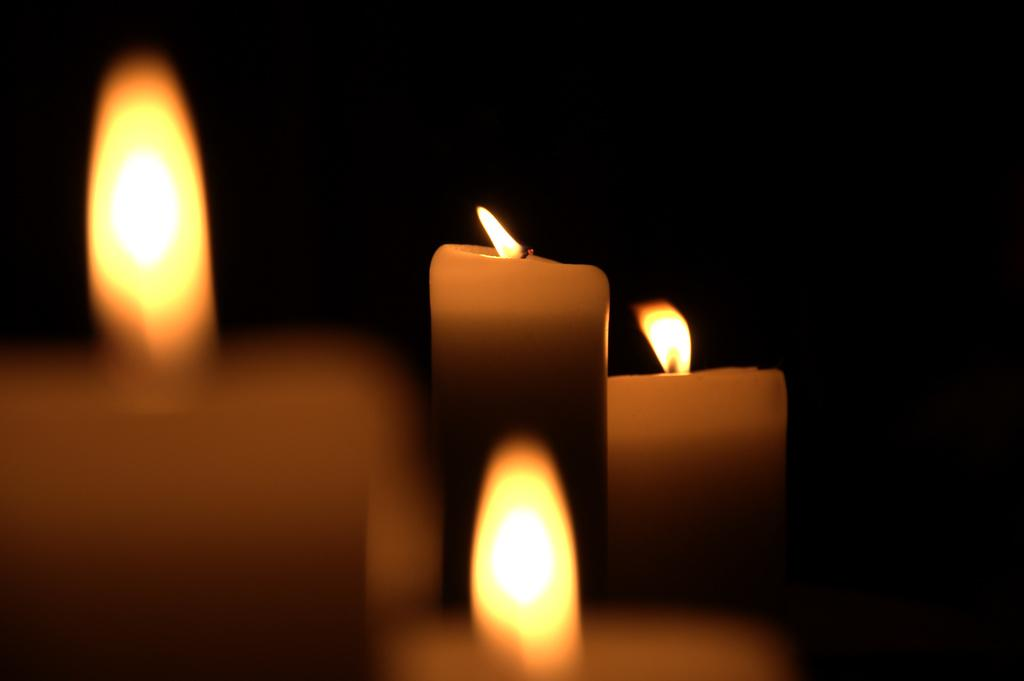What objects can be seen in the image? There are candles in the image. What is the state of the candles? The candles are lit. What hobbies can be seen being practiced in the image? There are no hobbies being practiced in the image; it only features lit candles. Can you see any smoke coming from the candles in the image? The image does not show any smoke coming from the candles. 